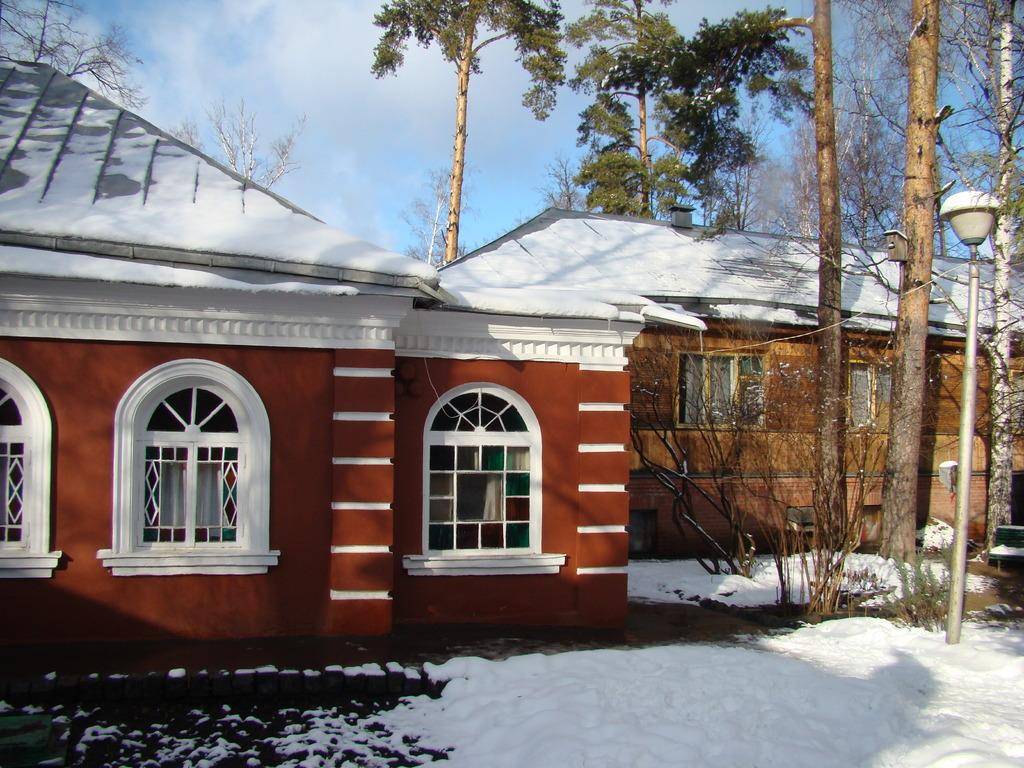What type of structure is visible in the image? There is a building with windows in the image. What is the condition of the ground in the image? There is snow on the ground in the image. What can be seen on the right side of the image? There are trees and a light pole on the right side of the image. What is visible in the background of the image? The sky is visible in the background of the image. How many copies of the root are visible in the image? There is no root present in the image. What type of cats can be seen playing in the snow in the image? There are no cats present in the image; it features a building, trees, a light pole, and snow on the ground. 